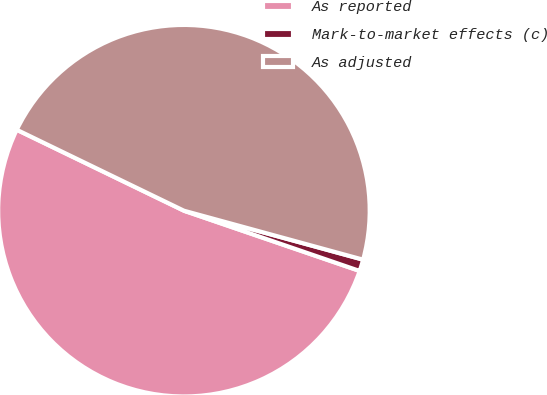Convert chart to OTSL. <chart><loc_0><loc_0><loc_500><loc_500><pie_chart><fcel>As reported<fcel>Mark-to-market effects (c)<fcel>As adjusted<nl><fcel>51.92%<fcel>1.01%<fcel>47.07%<nl></chart> 